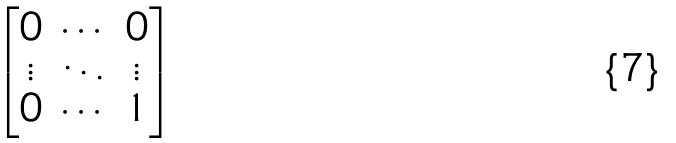Convert formula to latex. <formula><loc_0><loc_0><loc_500><loc_500>\begin{bmatrix} 0 & \cdots & 0 \\ \vdots & \ddots & \vdots \\ 0 & \cdots & 1 \end{bmatrix}</formula> 